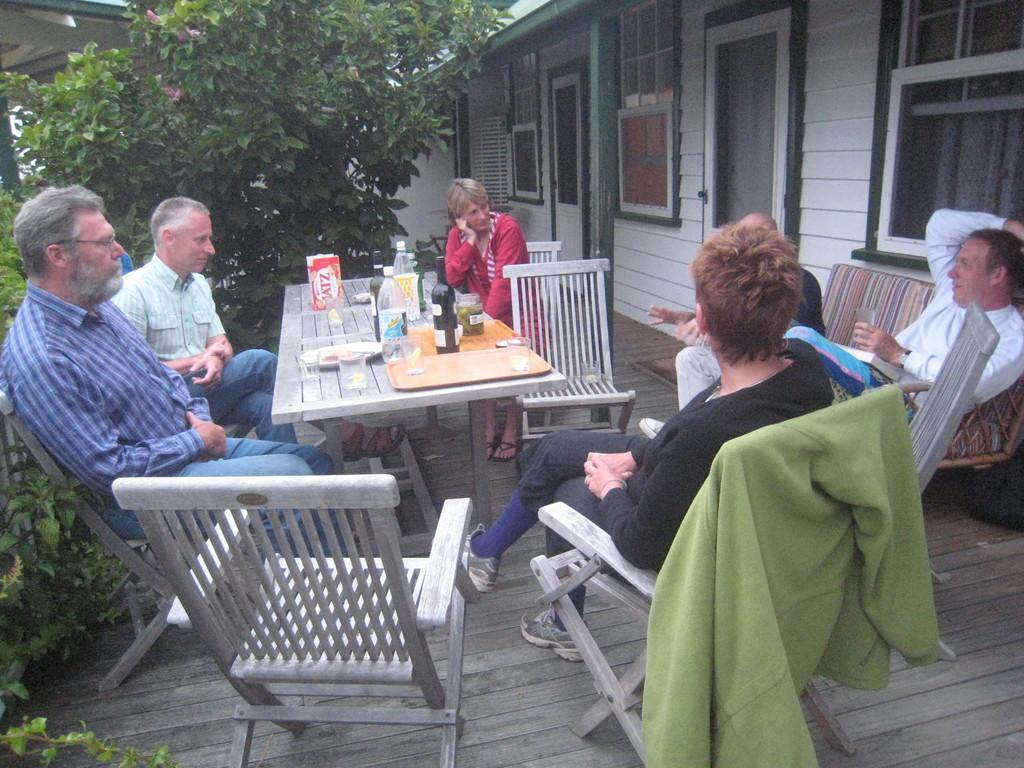Can you describe this image briefly? In this picture there are group of people who are sitting on a chair. There is a box, bottles, plate and few objects on the table. There is a tree and a house. 